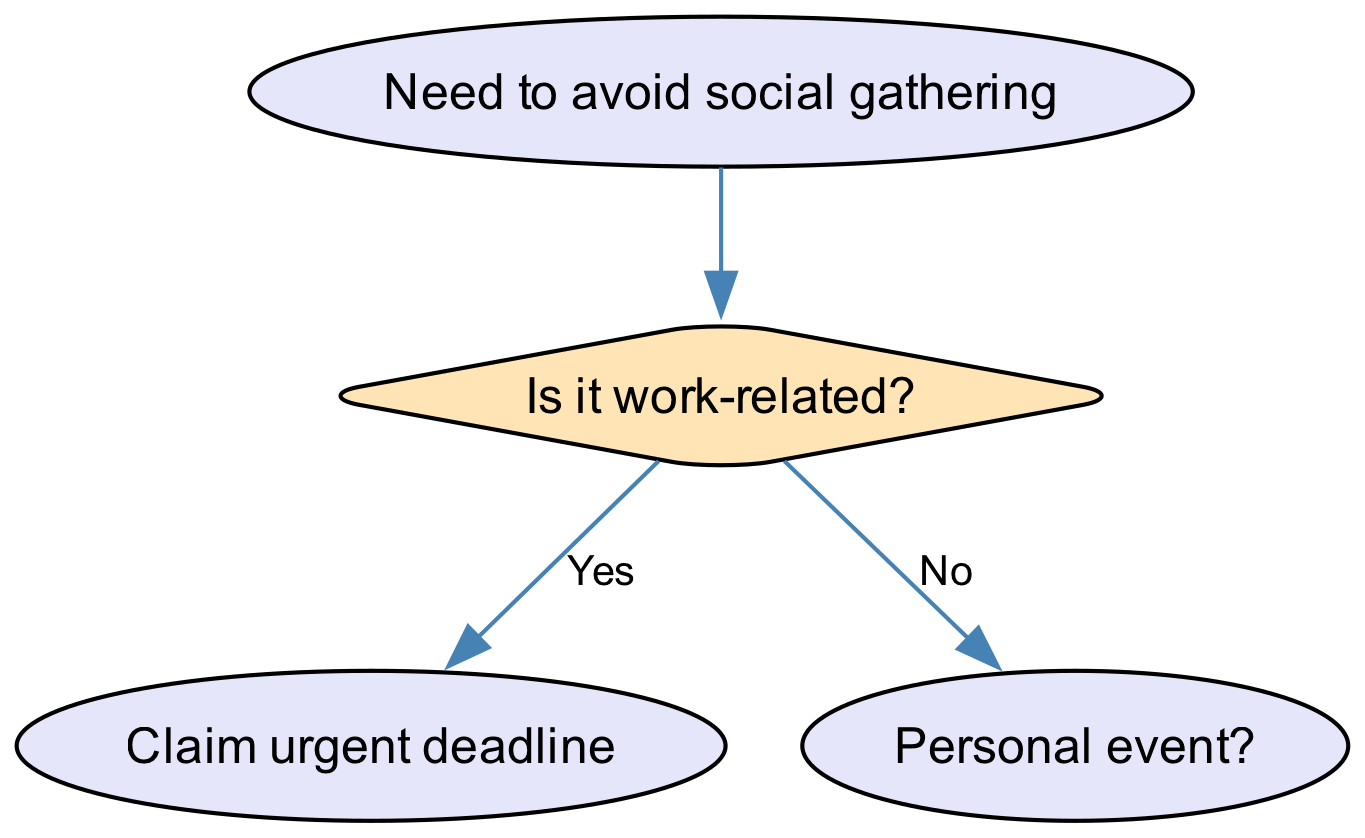What is the root node of the diagram? The root node of the diagram is "Need to avoid social gathering," as it is the starting point from which all other nodes branch out.
Answer: Need to avoid social gathering How many main branches does the root node have? The root node branches into two main paths: one for work-related excuses and one for personal excuses, totaling two branches.
Answer: 2 What excuse is suggested if the gathering is work-related? If the gathering is work-related, the suggested excuse is "Claim urgent deadline." This follows directly from the branch that addresses work-related scenarios.
Answer: Claim urgent deadline What happens in the case of bad weather? In the case of bad weather, the decision tree suggests "Car trouble due to weather," as this is the selected output based on the branch decision for bad weather.
Answer: Car trouble due to weather If it is not work-related and there's good weather, what excuse should be used? If it is not work-related and there is good weather, the appropriate excuse according to the diagram is "Sudden migraine attack," which follows the flow for non-work-related scenarios with good weather.
Answer: Sudden migraine attack How many total nodes are there in the diagram? There are a total of six nodes in the diagram, including one root node, two main branches stemming from it, and three subsequent nodes for the excuses.
Answer: 6 What is the final outcome if there is no personal event or preferable weather? The final outcome in such a case leads to "Invent family emergency," which is the excuse devised when there is neither a personal event nor favorable weather.
Answer: Invent family emergency Which decision leads to the excuse about car trouble? The decision that leads to the excuse about car trouble is "Bad weather," stemming from the initial query about whether it’s a personal event. From "No" for personal event, the next question pertains to weather, and bad weather prompts that specific excuse.
Answer: Bad weather What type of diagram is presented in this data structure? The type of diagram presented is a "Decision Tree," which is commonly used for making decisions based on a series of questions that branch out according to the responses received.
Answer: Decision Tree 